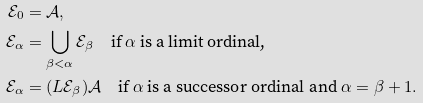Convert formula to latex. <formula><loc_0><loc_0><loc_500><loc_500>\mathcal { E } _ { 0 } & = \mathcal { A } , \\ \mathcal { E } _ { \alpha } & = \bigcup _ { \beta < \alpha } \mathcal { E } _ { \beta } \quad \text {if } \alpha \text { is a limit ordinal,} \\ \mathcal { E } _ { \alpha } & = ( L \mathcal { E } _ { \beta } ) \mathcal { A } \quad \text {if } \alpha \text { is a successor ordinal and } \alpha = \beta + 1 .</formula> 